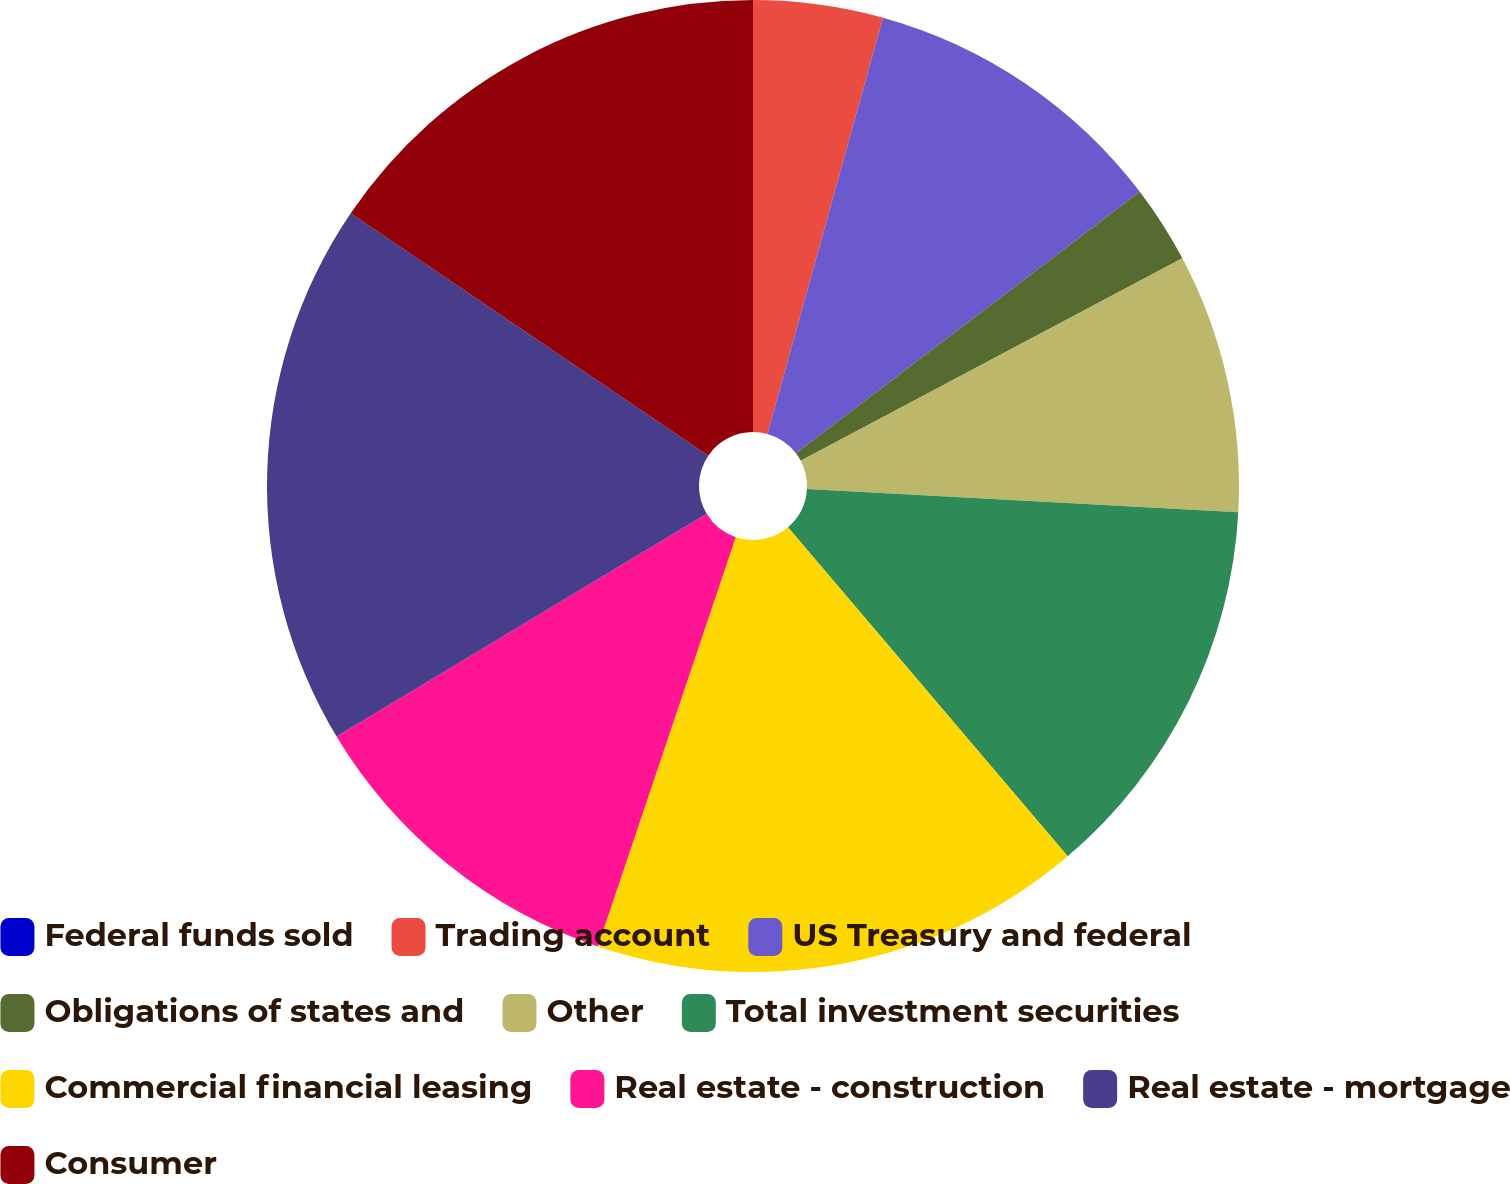Convert chart. <chart><loc_0><loc_0><loc_500><loc_500><pie_chart><fcel>Federal funds sold<fcel>Trading account<fcel>US Treasury and federal<fcel>Obligations of states and<fcel>Other<fcel>Total investment securities<fcel>Commercial financial leasing<fcel>Real estate - construction<fcel>Real estate - mortgage<fcel>Consumer<nl><fcel>0.0%<fcel>4.31%<fcel>10.34%<fcel>2.59%<fcel>8.62%<fcel>12.93%<fcel>16.38%<fcel>11.21%<fcel>18.1%<fcel>15.52%<nl></chart> 